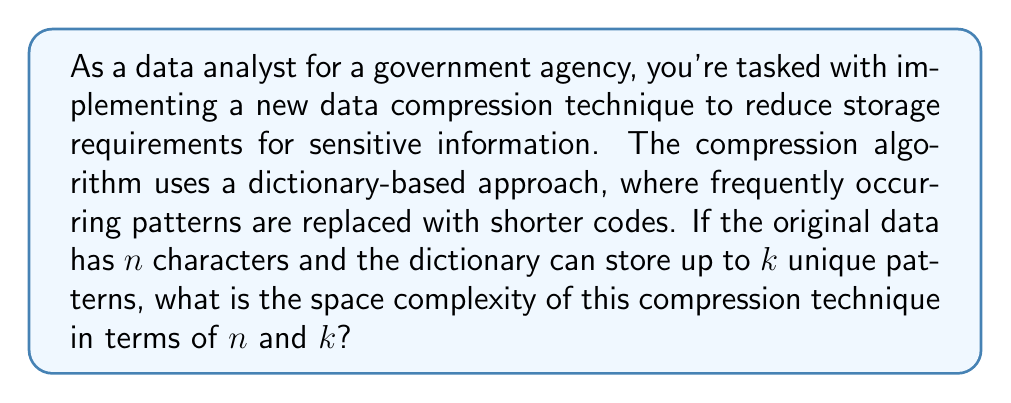Could you help me with this problem? To analyze the space complexity of this data compression technique, we need to consider two main components:

1. The compressed data:
   - In the worst case, if no patterns are found, the compressed data could be as large as the original data: $O(n)$

2. The dictionary:
   - The dictionary stores up to $k$ unique patterns
   - Each pattern could potentially be as long as the entire input string: $O(n)$
   - Therefore, the space required for the dictionary is: $O(k \cdot n)$

Combining these two components, the total space complexity is:

$$O(n) + O(k \cdot n) = O(n + kn) = O((k+1)n)$$

Since $k$ is typically a constant or grows much slower than $n$, we can simplify this to:

$$O((k+1)n) = O(n)$$

However, it's important to note that in practice, the actual space usage might be less than this worst-case scenario, as the purpose of compression is to reduce the data size. The effectiveness of the compression depends on the nature of the data and the specific patterns found.

For a government agency dealing with sensitive information, this space complexity analysis is crucial for ensuring that the compressed data doesn't unexpectedly exceed storage limits, which could potentially lead to data loss or security vulnerabilities.
Answer: The space complexity of the described data compression technique is $O(n)$, where $n$ is the number of characters in the original data. 